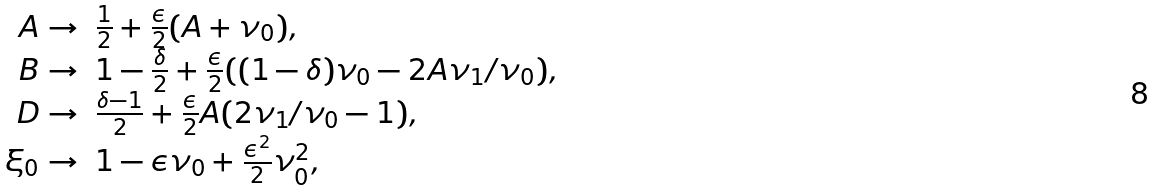<formula> <loc_0><loc_0><loc_500><loc_500>\begin{array} { r l } A \rightarrow & \frac { 1 } { 2 } + \frac { \epsilon } { 2 } ( A + \nu _ { 0 } ) , \\ B \rightarrow & 1 - \frac { \delta } { 2 } + \frac { \epsilon } { 2 } ( ( 1 - \delta ) \nu _ { 0 } - 2 A \nu _ { 1 } / \nu _ { 0 } ) , \\ D \rightarrow & \frac { \delta - 1 } { 2 } + \frac { \epsilon } { 2 } A ( 2 \nu _ { 1 } / \nu _ { 0 } - 1 ) , \\ \xi _ { 0 } \rightarrow & 1 - \epsilon \nu _ { 0 } + \frac { \epsilon ^ { 2 } } { 2 } \nu _ { 0 } ^ { 2 } , \end{array}</formula> 